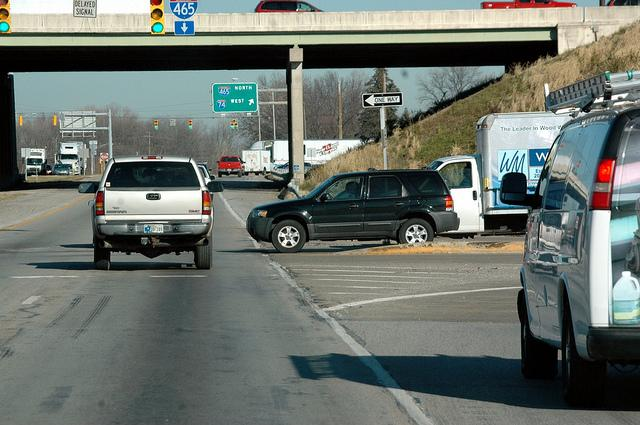How many traffic lights are hanging in the highway ahead facing toward the silver pickup truck? Please explain your reasoning. five. There are two in the front and 3 past the bridge 